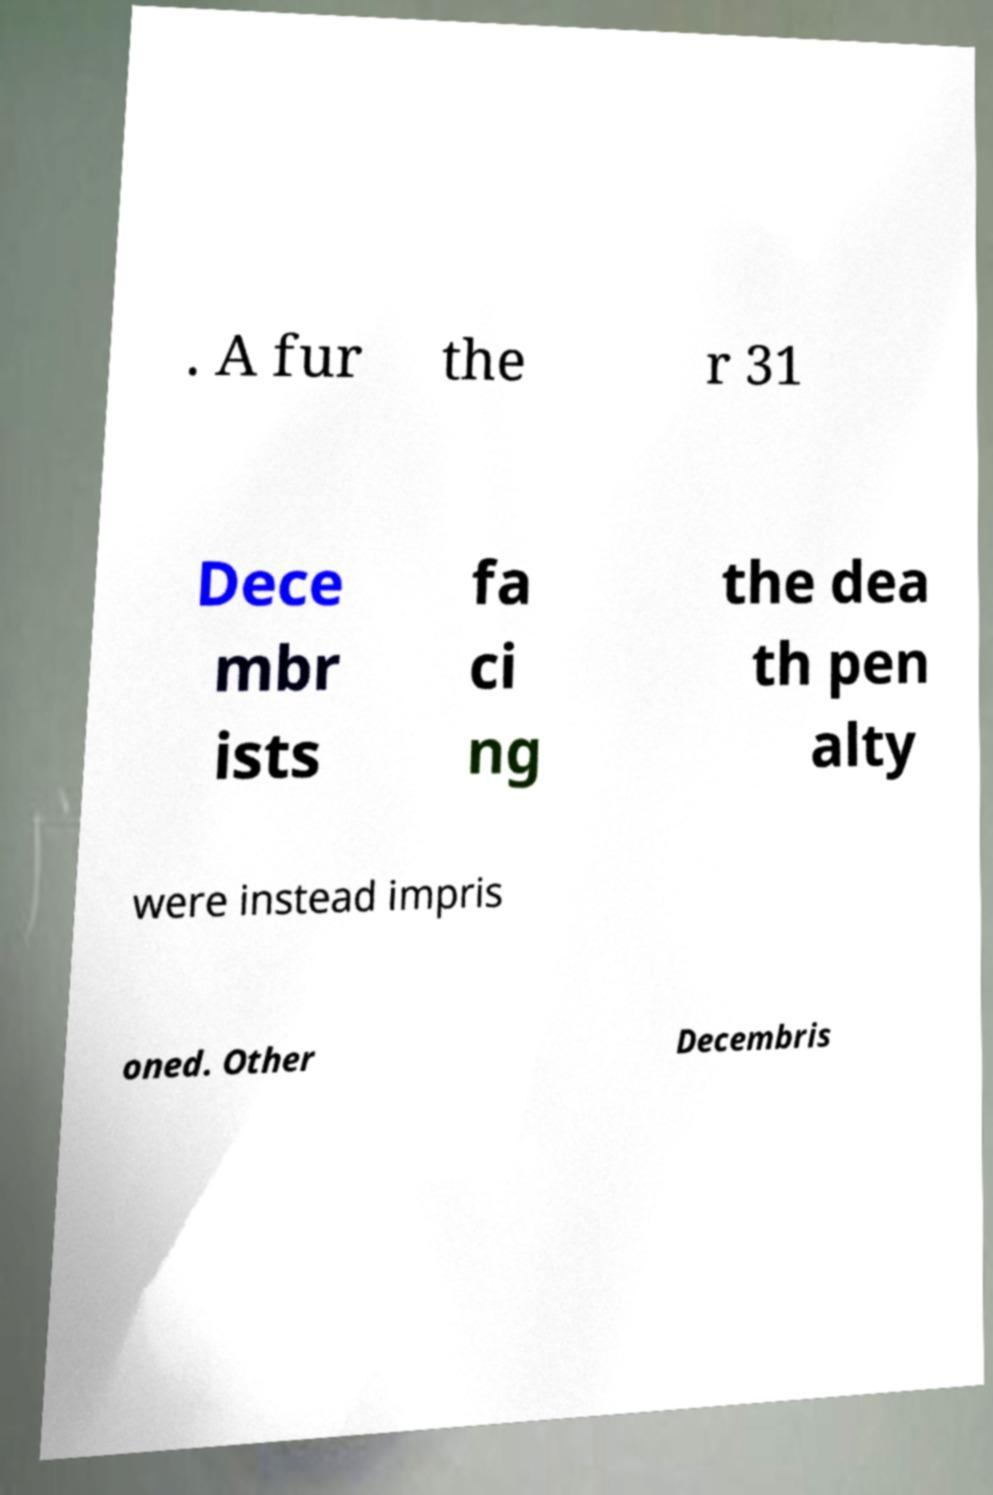Please identify and transcribe the text found in this image. . A fur the r 31 Dece mbr ists fa ci ng the dea th pen alty were instead impris oned. Other Decembris 